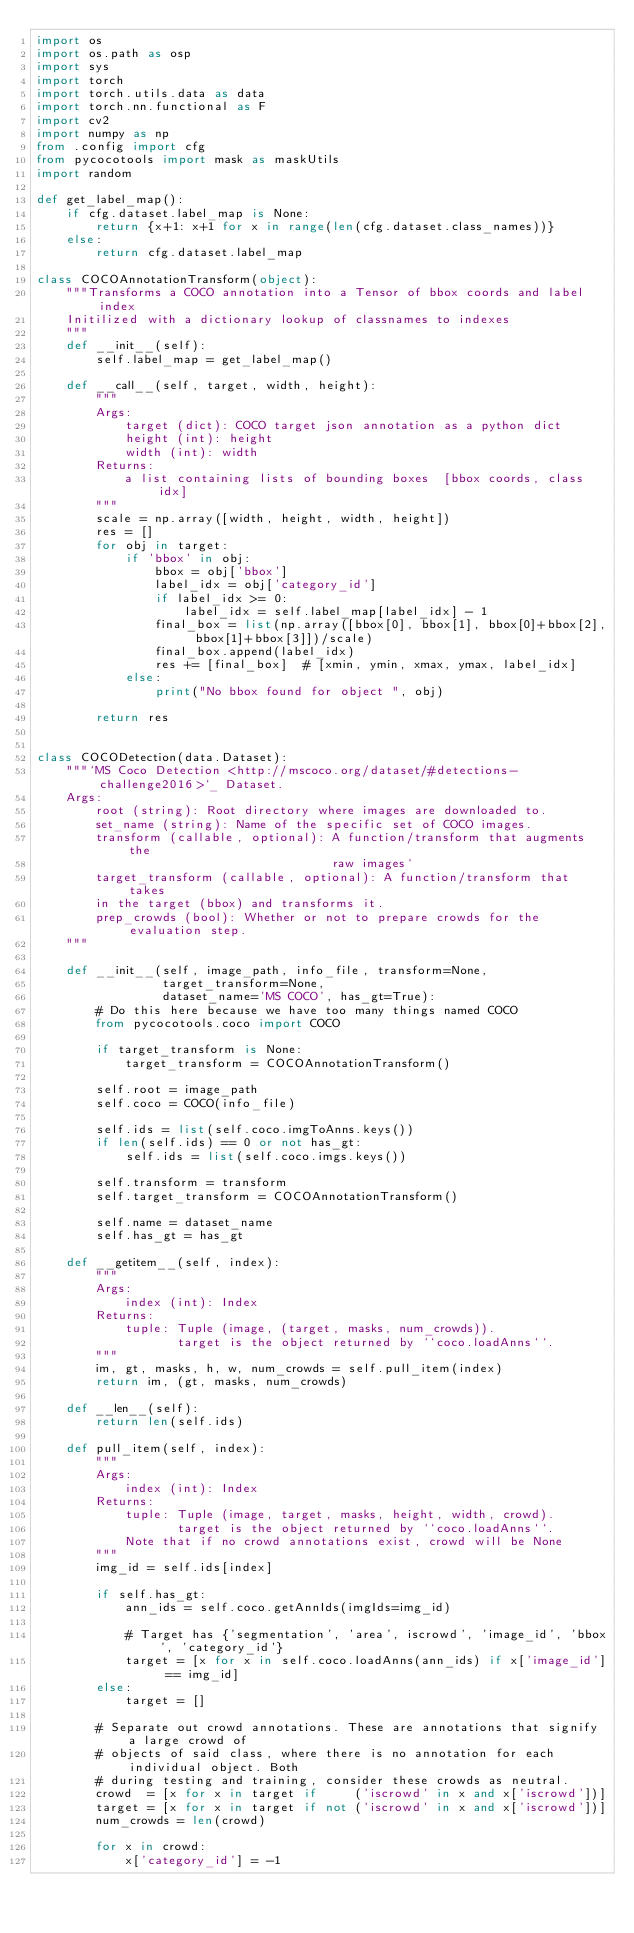Convert code to text. <code><loc_0><loc_0><loc_500><loc_500><_Python_>import os
import os.path as osp
import sys
import torch
import torch.utils.data as data
import torch.nn.functional as F
import cv2
import numpy as np
from .config import cfg
from pycocotools import mask as maskUtils
import random

def get_label_map():
    if cfg.dataset.label_map is None:
        return {x+1: x+1 for x in range(len(cfg.dataset.class_names))}
    else:
        return cfg.dataset.label_map 

class COCOAnnotationTransform(object):
    """Transforms a COCO annotation into a Tensor of bbox coords and label index
    Initilized with a dictionary lookup of classnames to indexes
    """
    def __init__(self):
        self.label_map = get_label_map()

    def __call__(self, target, width, height):
        """
        Args:
            target (dict): COCO target json annotation as a python dict
            height (int): height
            width (int): width
        Returns:
            a list containing lists of bounding boxes  [bbox coords, class idx]
        """
        scale = np.array([width, height, width, height])
        res = []
        for obj in target:
            if 'bbox' in obj:
                bbox = obj['bbox']
                label_idx = obj['category_id']
                if label_idx >= 0:
                    label_idx = self.label_map[label_idx] - 1
                final_box = list(np.array([bbox[0], bbox[1], bbox[0]+bbox[2], bbox[1]+bbox[3]])/scale)
                final_box.append(label_idx)
                res += [final_box]  # [xmin, ymin, xmax, ymax, label_idx]
            else:
                print("No bbox found for object ", obj)

        return res


class COCODetection(data.Dataset):
    """`MS Coco Detection <http://mscoco.org/dataset/#detections-challenge2016>`_ Dataset.
    Args:
        root (string): Root directory where images are downloaded to.
        set_name (string): Name of the specific set of COCO images.
        transform (callable, optional): A function/transform that augments the
                                        raw images`
        target_transform (callable, optional): A function/transform that takes
        in the target (bbox) and transforms it.
        prep_crowds (bool): Whether or not to prepare crowds for the evaluation step.
    """

    def __init__(self, image_path, info_file, transform=None,
                 target_transform=None,
                 dataset_name='MS COCO', has_gt=True):
        # Do this here because we have too many things named COCO
        from pycocotools.coco import COCO
        
        if target_transform is None:
            target_transform = COCOAnnotationTransform()

        self.root = image_path
        self.coco = COCO(info_file)
        
        self.ids = list(self.coco.imgToAnns.keys())
        if len(self.ids) == 0 or not has_gt:
            self.ids = list(self.coco.imgs.keys())
        
        self.transform = transform
        self.target_transform = COCOAnnotationTransform()
        
        self.name = dataset_name
        self.has_gt = has_gt

    def __getitem__(self, index):
        """
        Args:
            index (int): Index
        Returns:
            tuple: Tuple (image, (target, masks, num_crowds)).
                   target is the object returned by ``coco.loadAnns``.
        """
        im, gt, masks, h, w, num_crowds = self.pull_item(index)
        return im, (gt, masks, num_crowds)

    def __len__(self):
        return len(self.ids)

    def pull_item(self, index):
        """
        Args:
            index (int): Index
        Returns:
            tuple: Tuple (image, target, masks, height, width, crowd).
                   target is the object returned by ``coco.loadAnns``.
            Note that if no crowd annotations exist, crowd will be None
        """
        img_id = self.ids[index]

        if self.has_gt:
            ann_ids = self.coco.getAnnIds(imgIds=img_id)

            # Target has {'segmentation', 'area', iscrowd', 'image_id', 'bbox', 'category_id'}
            target = [x for x in self.coco.loadAnns(ann_ids) if x['image_id'] == img_id]
        else:
            target = []

        # Separate out crowd annotations. These are annotations that signify a large crowd of
        # objects of said class, where there is no annotation for each individual object. Both
        # during testing and training, consider these crowds as neutral.
        crowd  = [x for x in target if     ('iscrowd' in x and x['iscrowd'])]
        target = [x for x in target if not ('iscrowd' in x and x['iscrowd'])]
        num_crowds = len(crowd)

        for x in crowd:
            x['category_id'] = -1
</code> 